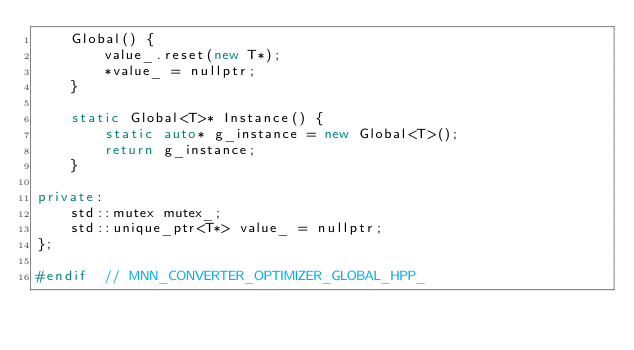<code> <loc_0><loc_0><loc_500><loc_500><_C++_>    Global() {
        value_.reset(new T*);
        *value_ = nullptr;
    }

    static Global<T>* Instance() {
        static auto* g_instance = new Global<T>();
        return g_instance;
    }

private:
    std::mutex mutex_;
    std::unique_ptr<T*> value_ = nullptr;
};

#endif  // MNN_CONVERTER_OPTIMIZER_GLOBAL_HPP_
</code> 